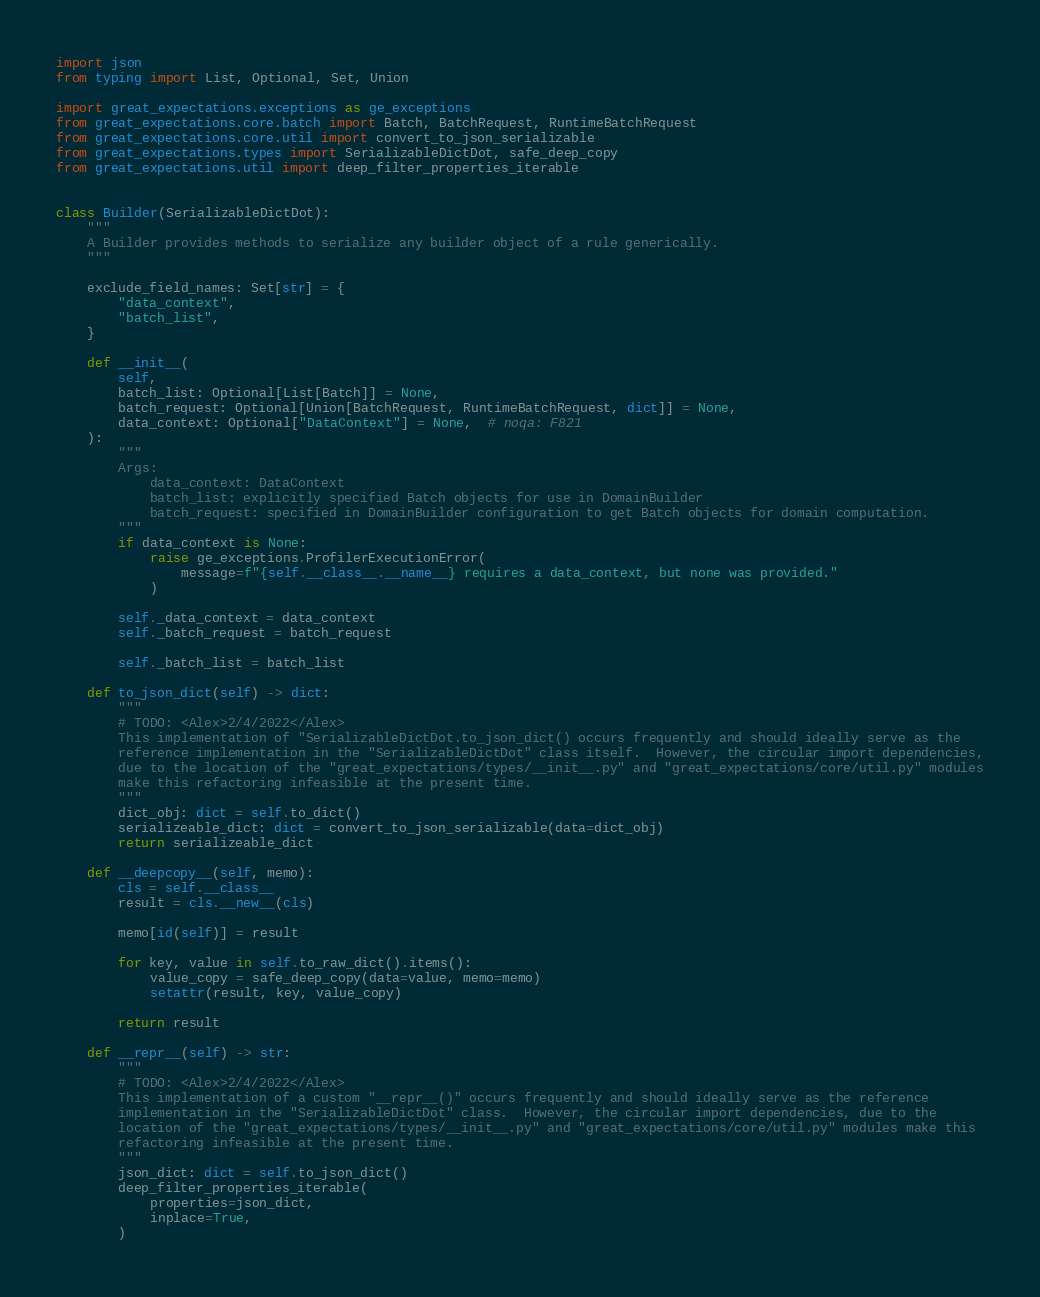<code> <loc_0><loc_0><loc_500><loc_500><_Python_>import json
from typing import List, Optional, Set, Union

import great_expectations.exceptions as ge_exceptions
from great_expectations.core.batch import Batch, BatchRequest, RuntimeBatchRequest
from great_expectations.core.util import convert_to_json_serializable
from great_expectations.types import SerializableDictDot, safe_deep_copy
from great_expectations.util import deep_filter_properties_iterable


class Builder(SerializableDictDot):
    """
    A Builder provides methods to serialize any builder object of a rule generically.
    """

    exclude_field_names: Set[str] = {
        "data_context",
        "batch_list",
    }

    def __init__(
        self,
        batch_list: Optional[List[Batch]] = None,
        batch_request: Optional[Union[BatchRequest, RuntimeBatchRequest, dict]] = None,
        data_context: Optional["DataContext"] = None,  # noqa: F821
    ):
        """
        Args:
            data_context: DataContext
            batch_list: explicitly specified Batch objects for use in DomainBuilder
            batch_request: specified in DomainBuilder configuration to get Batch objects for domain computation.
        """
        if data_context is None:
            raise ge_exceptions.ProfilerExecutionError(
                message=f"{self.__class__.__name__} requires a data_context, but none was provided."
            )

        self._data_context = data_context
        self._batch_request = batch_request

        self._batch_list = batch_list

    def to_json_dict(self) -> dict:
        """
        # TODO: <Alex>2/4/2022</Alex>
        This implementation of "SerializableDictDot.to_json_dict() occurs frequently and should ideally serve as the
        reference implementation in the "SerializableDictDot" class itself.  However, the circular import dependencies,
        due to the location of the "great_expectations/types/__init__.py" and "great_expectations/core/util.py" modules
        make this refactoring infeasible at the present time.
        """
        dict_obj: dict = self.to_dict()
        serializeable_dict: dict = convert_to_json_serializable(data=dict_obj)
        return serializeable_dict

    def __deepcopy__(self, memo):
        cls = self.__class__
        result = cls.__new__(cls)

        memo[id(self)] = result

        for key, value in self.to_raw_dict().items():
            value_copy = safe_deep_copy(data=value, memo=memo)
            setattr(result, key, value_copy)

        return result

    def __repr__(self) -> str:
        """
        # TODO: <Alex>2/4/2022</Alex>
        This implementation of a custom "__repr__()" occurs frequently and should ideally serve as the reference
        implementation in the "SerializableDictDot" class.  However, the circular import dependencies, due to the
        location of the "great_expectations/types/__init__.py" and "great_expectations/core/util.py" modules make this
        refactoring infeasible at the present time.
        """
        json_dict: dict = self.to_json_dict()
        deep_filter_properties_iterable(
            properties=json_dict,
            inplace=True,
        )</code> 